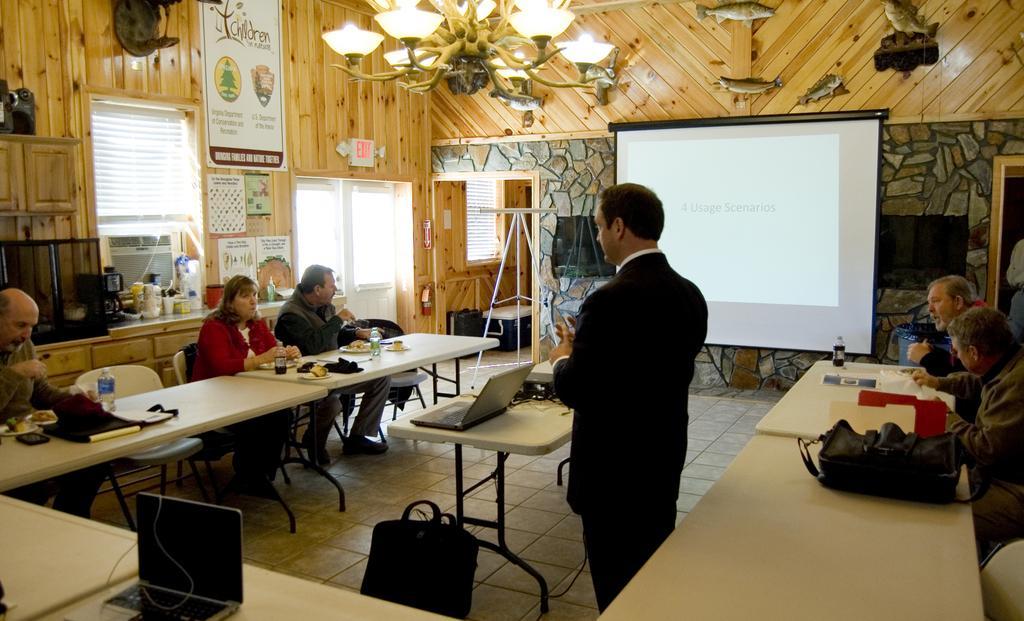Describe this image in one or two sentences. On top there are lights. Different type of posters on wall. Beside this wall there is a screen. This person is standing. On this tablet there is a bag, laptops, bottles and things. Beside this tables persons are sitting on chairs. 